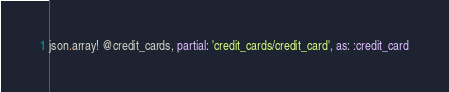<code> <loc_0><loc_0><loc_500><loc_500><_Ruby_>json.array! @credit_cards, partial: 'credit_cards/credit_card', as: :credit_card
</code> 